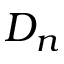Convert formula to latex. <formula><loc_0><loc_0><loc_500><loc_500>D _ { n }</formula> 